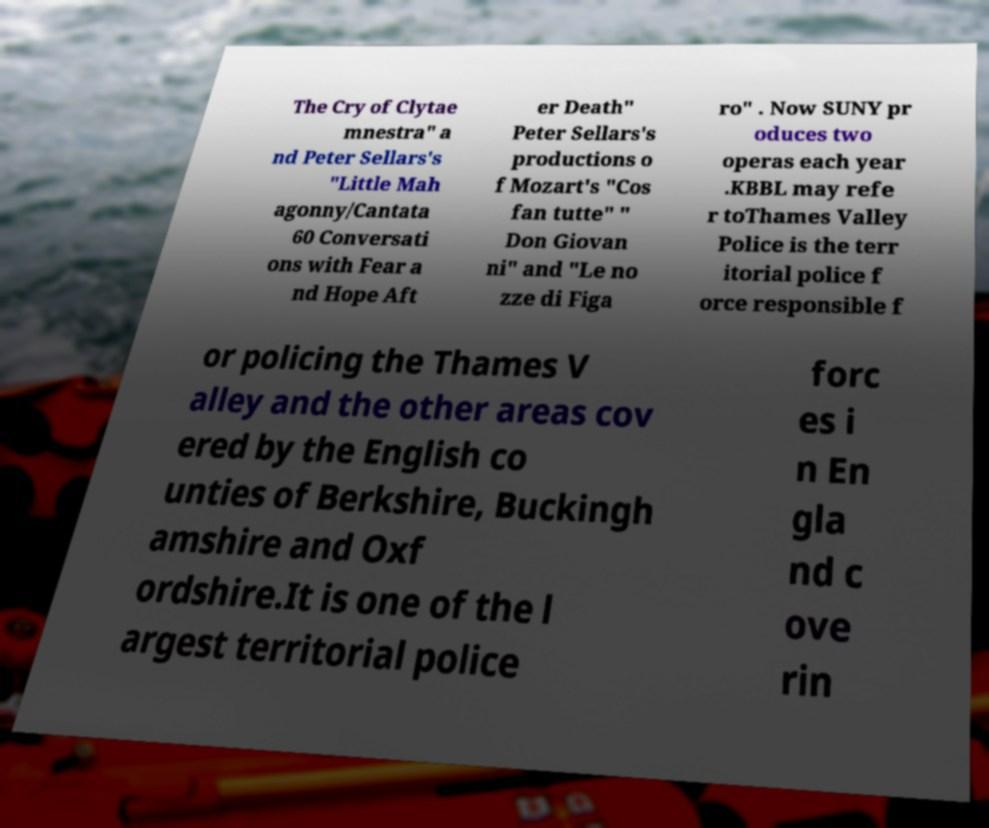Could you assist in decoding the text presented in this image and type it out clearly? The Cry of Clytae mnestra" a nd Peter Sellars's "Little Mah agonny/Cantata 60 Conversati ons with Fear a nd Hope Aft er Death" Peter Sellars's productions o f Mozart's "Cos fan tutte" " Don Giovan ni" and "Le no zze di Figa ro" . Now SUNY pr oduces two operas each year .KBBL may refe r toThames Valley Police is the terr itorial police f orce responsible f or policing the Thames V alley and the other areas cov ered by the English co unties of Berkshire, Buckingh amshire and Oxf ordshire.It is one of the l argest territorial police forc es i n En gla nd c ove rin 